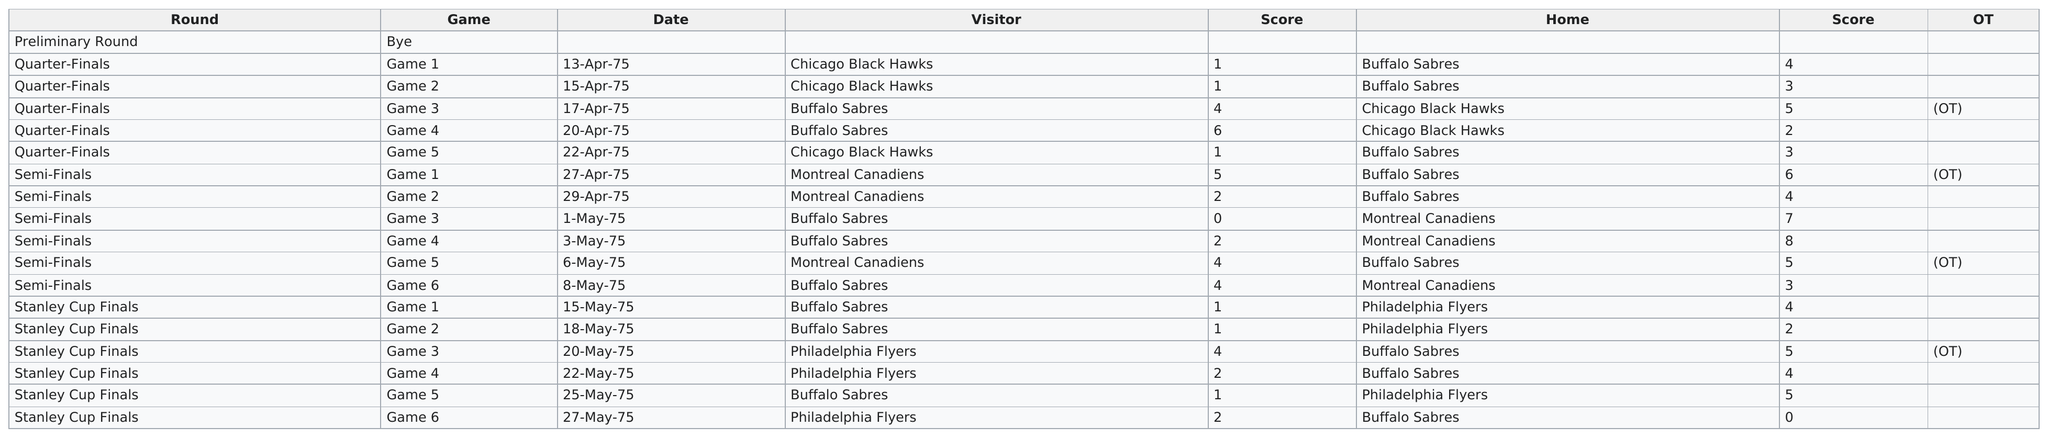Mention a couple of crucial points in this snapshot. The least amount of games were held in April. The Sabres scored a total of 53 points in their recent run of games. The Buffalo Sabres' score in their most recent game was 0. In the 1975 Stanley Cup Playoffs, the Buffalo Sabres played a total of 9 home games. The date of the last playoff game was May 27, 1975. 